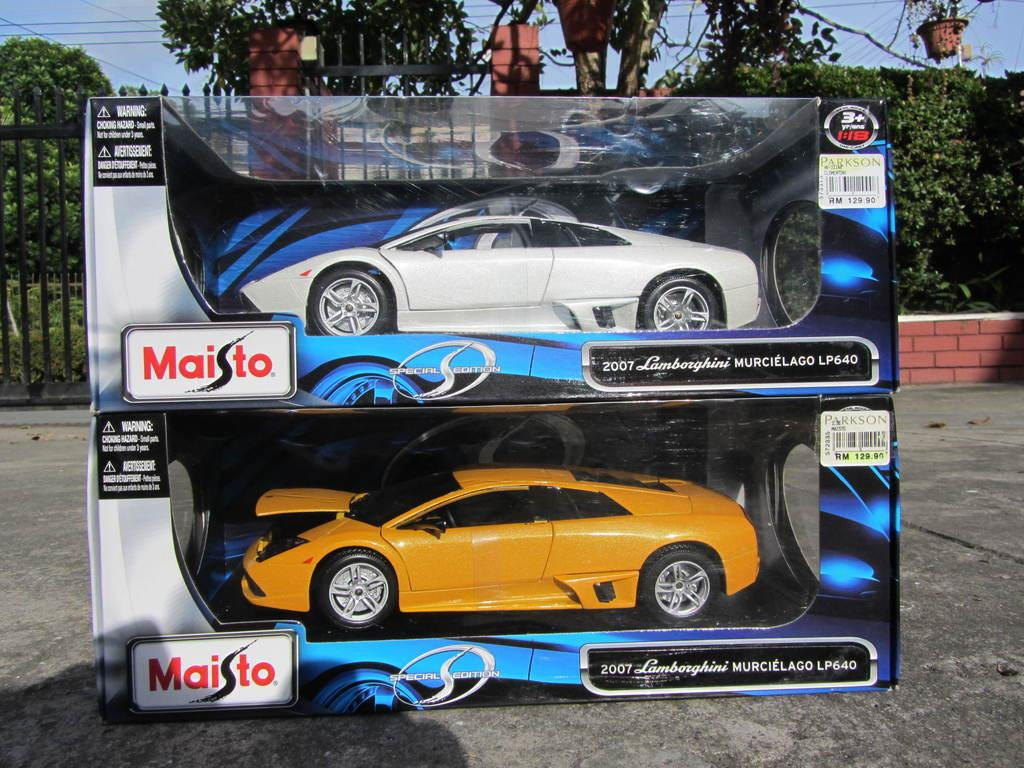What is inside the boxes in the image? There are cars in boxes in the image. What can be seen in the background of the image? There is a wall, trees, and the sky visible in the background of the image. What type of instrument is being played in the church in the image? There is no church or instrument present in the image; it features cars in boxes and a background with a wall, trees, and sky. 